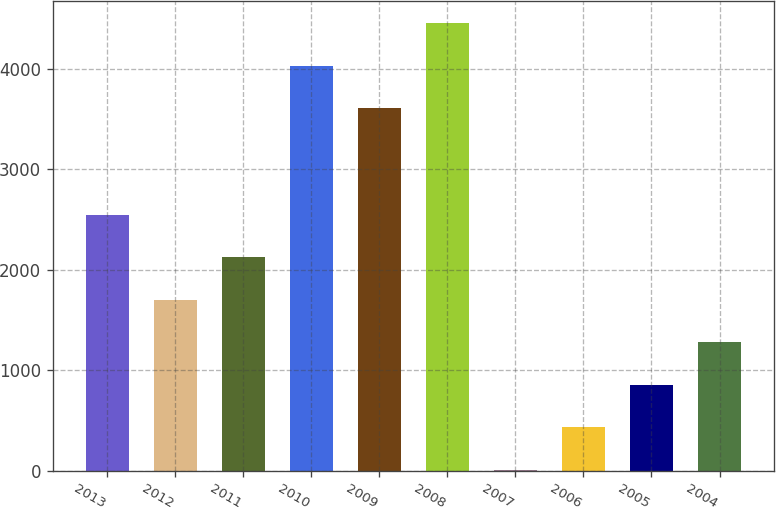<chart> <loc_0><loc_0><loc_500><loc_500><bar_chart><fcel>2013<fcel>2012<fcel>2011<fcel>2010<fcel>2009<fcel>2008<fcel>2007<fcel>2006<fcel>2005<fcel>2004<nl><fcel>2548.2<fcel>1701.8<fcel>2125<fcel>4032.2<fcel>3609<fcel>4455.4<fcel>9<fcel>432.2<fcel>855.4<fcel>1278.6<nl></chart> 